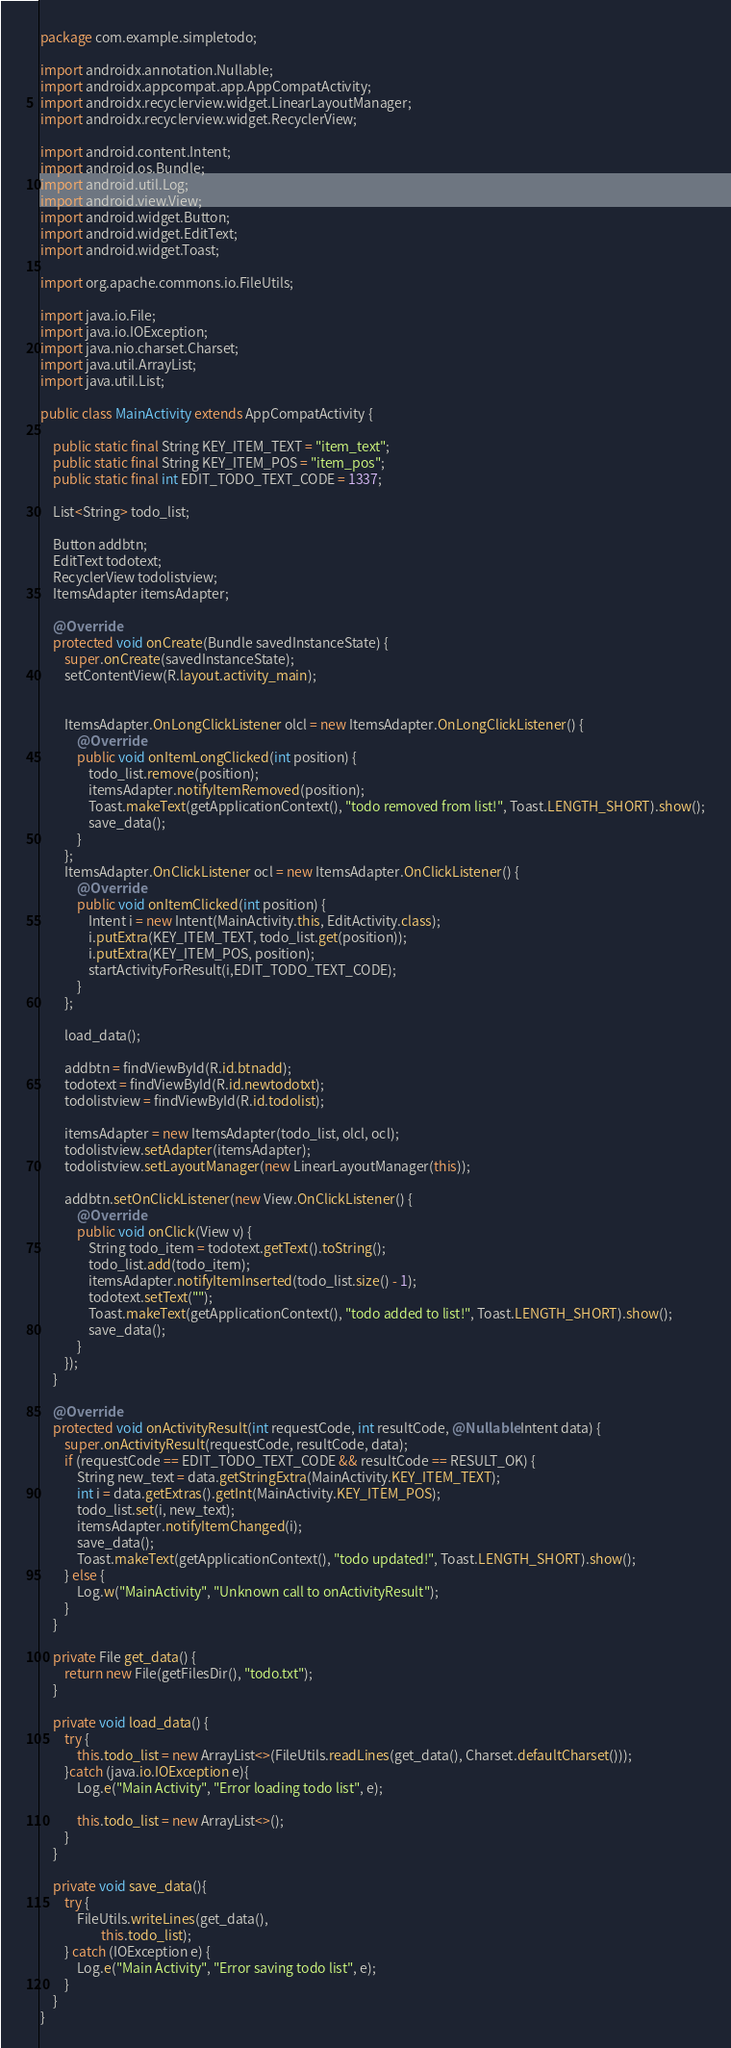Convert code to text. <code><loc_0><loc_0><loc_500><loc_500><_Java_>package com.example.simpletodo;

import androidx.annotation.Nullable;
import androidx.appcompat.app.AppCompatActivity;
import androidx.recyclerview.widget.LinearLayoutManager;
import androidx.recyclerview.widget.RecyclerView;

import android.content.Intent;
import android.os.Bundle;
import android.util.Log;
import android.view.View;
import android.widget.Button;
import android.widget.EditText;
import android.widget.Toast;

import org.apache.commons.io.FileUtils;

import java.io.File;
import java.io.IOException;
import java.nio.charset.Charset;
import java.util.ArrayList;
import java.util.List;

public class MainActivity extends AppCompatActivity {

    public static final String KEY_ITEM_TEXT = "item_text";
    public static final String KEY_ITEM_POS = "item_pos";
    public static final int EDIT_TODO_TEXT_CODE = 1337;

    List<String> todo_list;

    Button addbtn;
    EditText todotext;
    RecyclerView todolistview;
    ItemsAdapter itemsAdapter;

    @Override
    protected void onCreate(Bundle savedInstanceState) {
        super.onCreate(savedInstanceState);
        setContentView(R.layout.activity_main);


        ItemsAdapter.OnLongClickListener olcl = new ItemsAdapter.OnLongClickListener() {
            @Override
            public void onItemLongClicked(int position) {
                todo_list.remove(position);
                itemsAdapter.notifyItemRemoved(position);
                Toast.makeText(getApplicationContext(), "todo removed from list!", Toast.LENGTH_SHORT).show();
                save_data();
            }
        };
        ItemsAdapter.OnClickListener ocl = new ItemsAdapter.OnClickListener() {
            @Override
            public void onItemClicked(int position) {
                Intent i = new Intent(MainActivity.this, EditActivity.class);
                i.putExtra(KEY_ITEM_TEXT, todo_list.get(position));
                i.putExtra(KEY_ITEM_POS, position);
                startActivityForResult(i,EDIT_TODO_TEXT_CODE);
            }
        };

        load_data();

        addbtn = findViewById(R.id.btnadd);
        todotext = findViewById(R.id.newtodotxt);
        todolistview = findViewById(R.id.todolist);

        itemsAdapter = new ItemsAdapter(todo_list, olcl, ocl);
        todolistview.setAdapter(itemsAdapter);
        todolistview.setLayoutManager(new LinearLayoutManager(this));

        addbtn.setOnClickListener(new View.OnClickListener() {
            @Override
            public void onClick(View v) {
                String todo_item = todotext.getText().toString();
                todo_list.add(todo_item);
                itemsAdapter.notifyItemInserted(todo_list.size() - 1);
                todotext.setText("");
                Toast.makeText(getApplicationContext(), "todo added to list!", Toast.LENGTH_SHORT).show();
                save_data();
            }
        });
    }

    @Override
    protected void onActivityResult(int requestCode, int resultCode, @Nullable Intent data) {
        super.onActivityResult(requestCode, resultCode, data);
        if (requestCode == EDIT_TODO_TEXT_CODE && resultCode == RESULT_OK) {
            String new_text = data.getStringExtra(MainActivity.KEY_ITEM_TEXT);
            int i = data.getExtras().getInt(MainActivity.KEY_ITEM_POS);
            todo_list.set(i, new_text);
            itemsAdapter.notifyItemChanged(i);
            save_data();
            Toast.makeText(getApplicationContext(), "todo updated!", Toast.LENGTH_SHORT).show();
        } else {
            Log.w("MainActivity", "Unknown call to onActivityResult");
        }
    }

    private File get_data() {
        return new File(getFilesDir(), "todo.txt");
    }

    private void load_data() {
        try {
            this.todo_list = new ArrayList<>(FileUtils.readLines(get_data(), Charset.defaultCharset()));
        }catch (java.io.IOException e){
            Log.e("Main Activity", "Error loading todo list", e);

            this.todo_list = new ArrayList<>();
        }
    }

    private void save_data(){
        try {
            FileUtils.writeLines(get_data(),
                    this.todo_list);
        } catch (IOException e) {
            Log.e("Main Activity", "Error saving todo list", e);
        }
    }
}</code> 